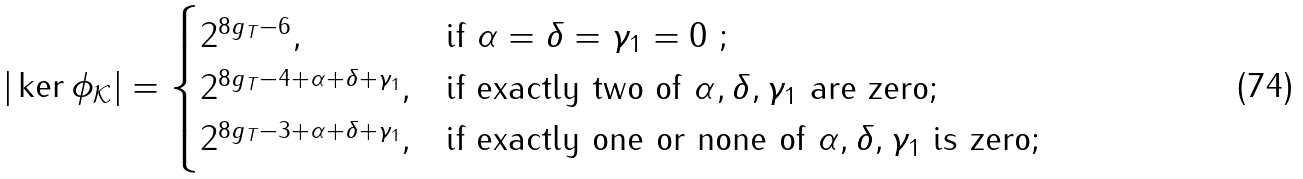<formula> <loc_0><loc_0><loc_500><loc_500>| \ker \phi _ { \mathcal { K } } | = \begin{cases} 2 ^ { 8 g _ { T } - 6 } , & \text {if $\alpha = \delta = \gamma_{1} = 0$ ;} \\ 2 ^ { 8 g _ { T } - 4 + \alpha + \delta + \gamma _ { 1 } } , & \text {if exactly two of $\alpha , \delta ,     \gamma_{1}$ are zero;} \\ 2 ^ { 8 g _ { T } - 3 + \alpha + \delta + \gamma _ { 1 } } , & \text {if exactly one or none of $\alpha ,     \delta , \gamma_{1}$ is zero;} \end{cases}</formula> 